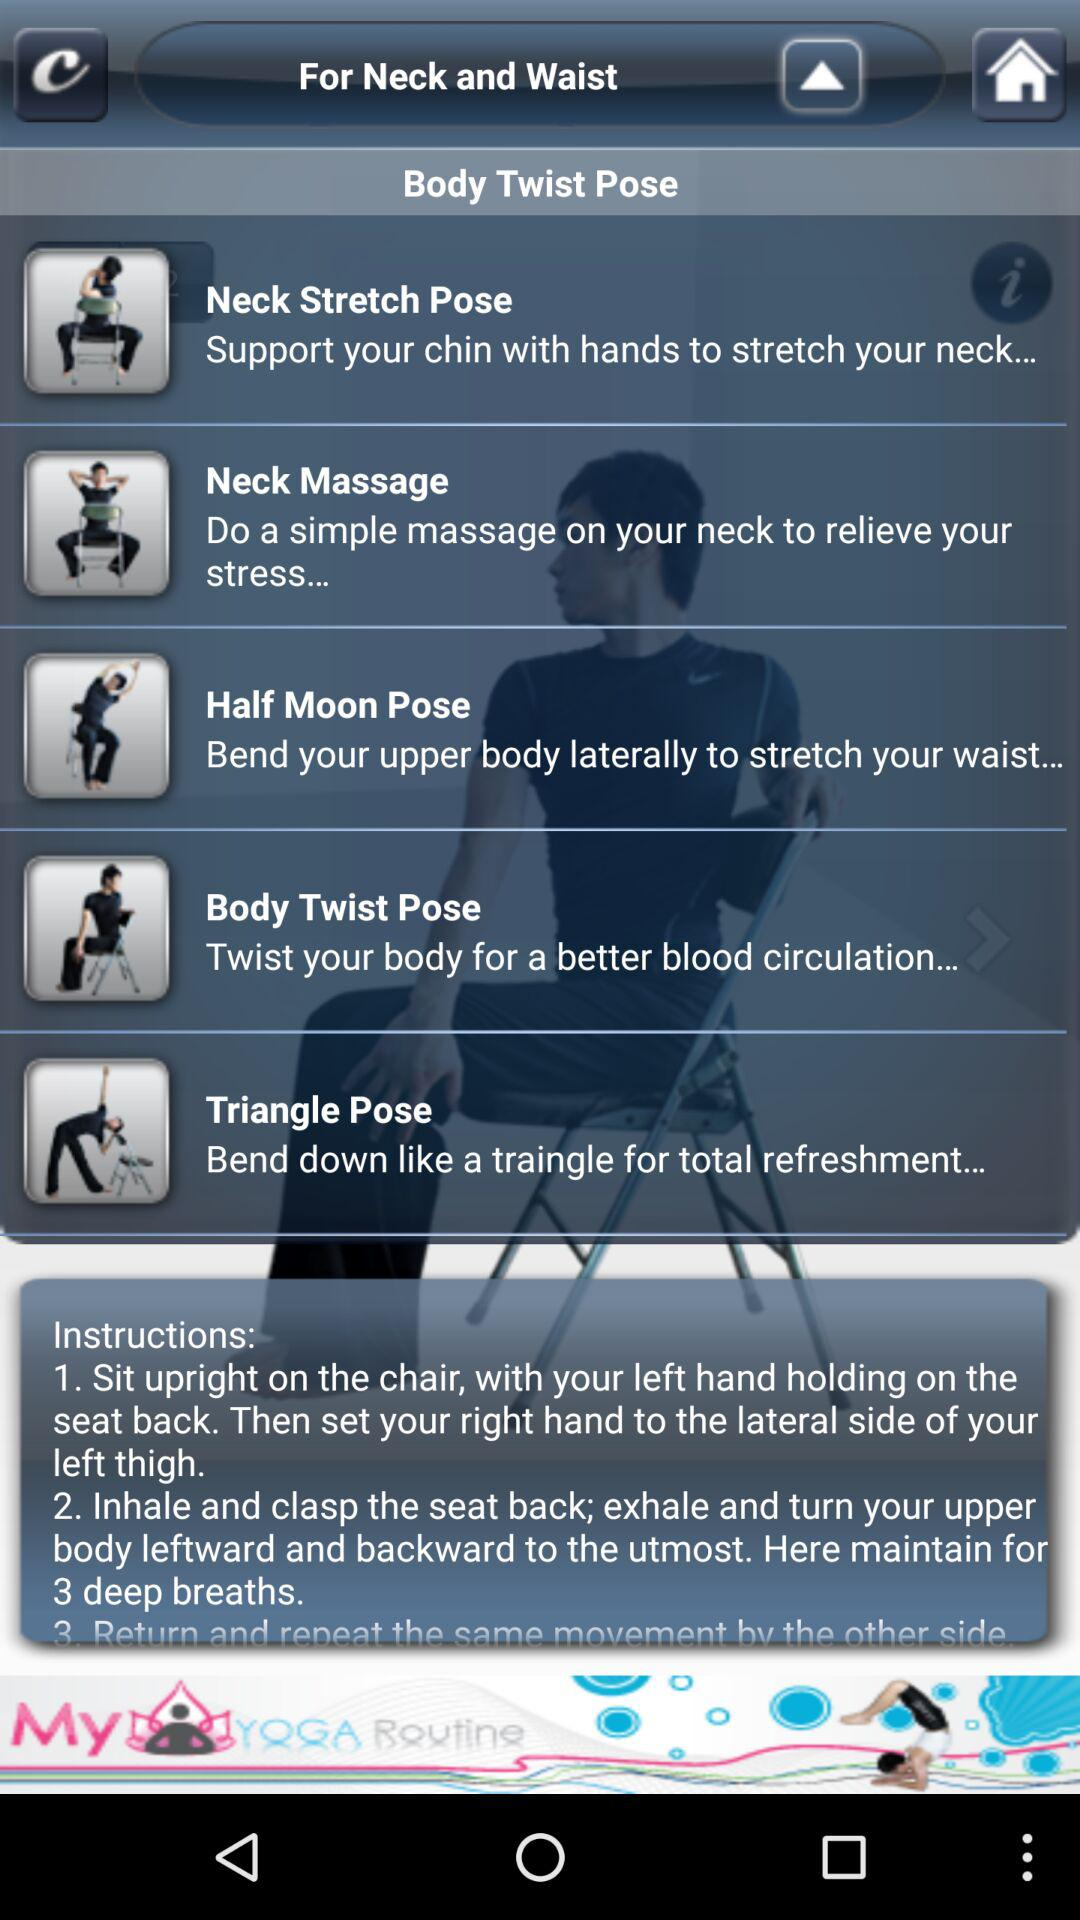How long does it take to do "Triangle Pose"?
When the provided information is insufficient, respond with <no answer>. <no answer> 